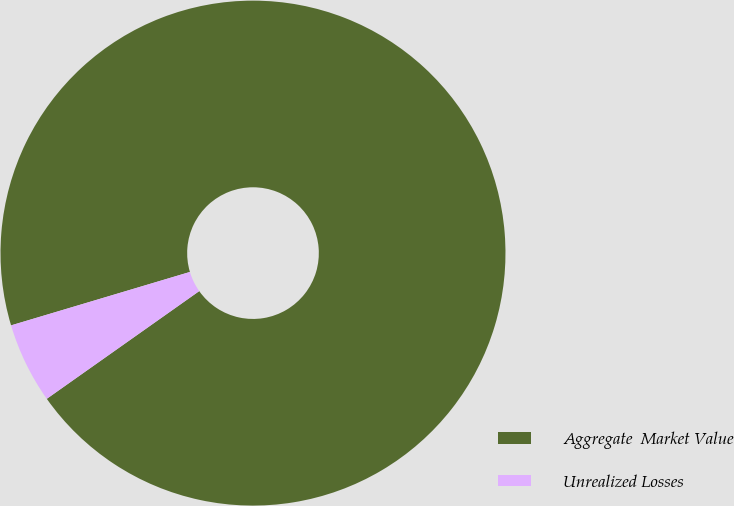Convert chart. <chart><loc_0><loc_0><loc_500><loc_500><pie_chart><fcel>Aggregate  Market Value<fcel>Unrealized Losses<nl><fcel>94.83%<fcel>5.17%<nl></chart> 